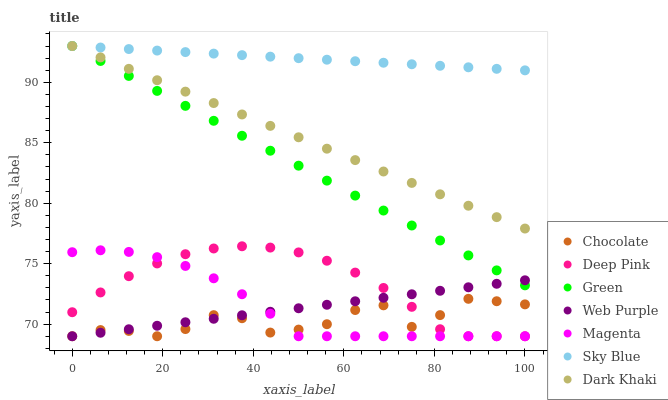Does Chocolate have the minimum area under the curve?
Answer yes or no. Yes. Does Sky Blue have the maximum area under the curve?
Answer yes or no. Yes. Does Dark Khaki have the minimum area under the curve?
Answer yes or no. No. Does Dark Khaki have the maximum area under the curve?
Answer yes or no. No. Is Dark Khaki the smoothest?
Answer yes or no. Yes. Is Chocolate the roughest?
Answer yes or no. Yes. Is Chocolate the smoothest?
Answer yes or no. No. Is Dark Khaki the roughest?
Answer yes or no. No. Does Deep Pink have the lowest value?
Answer yes or no. Yes. Does Dark Khaki have the lowest value?
Answer yes or no. No. Does Sky Blue have the highest value?
Answer yes or no. Yes. Does Chocolate have the highest value?
Answer yes or no. No. Is Chocolate less than Green?
Answer yes or no. Yes. Is Sky Blue greater than Chocolate?
Answer yes or no. Yes. Does Sky Blue intersect Green?
Answer yes or no. Yes. Is Sky Blue less than Green?
Answer yes or no. No. Is Sky Blue greater than Green?
Answer yes or no. No. Does Chocolate intersect Green?
Answer yes or no. No. 